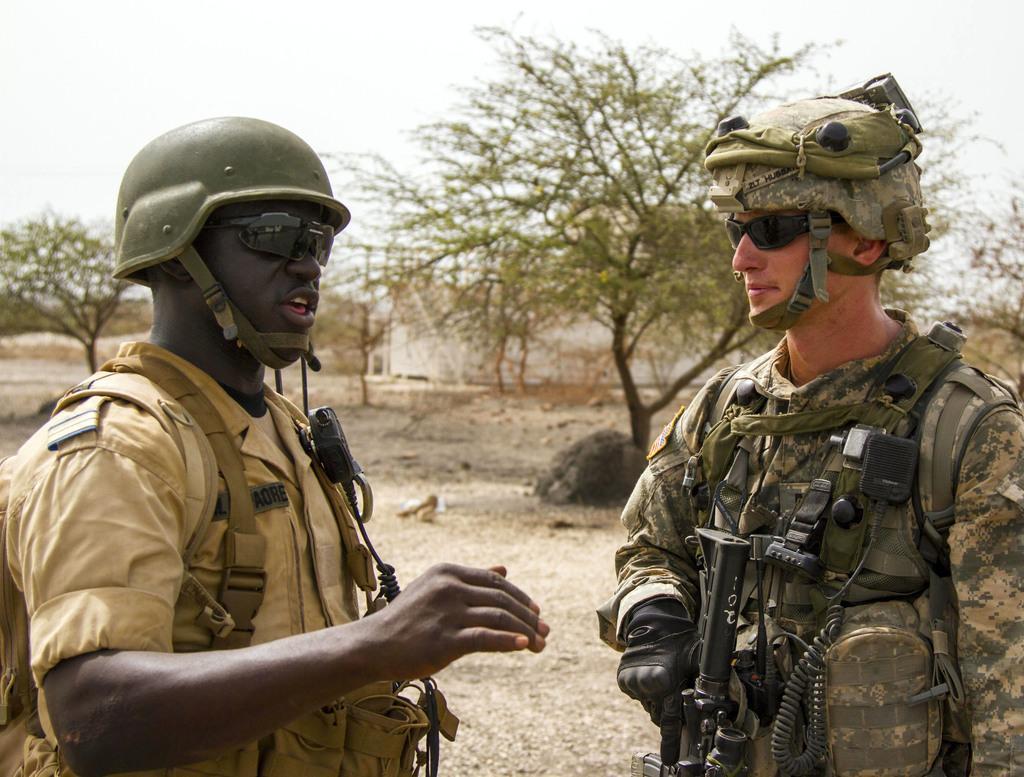Please provide a concise description of this image. In this image we can see two persons with uniform and helmets, a person is holding a gun and in the background there are trees, stone and the sky. 